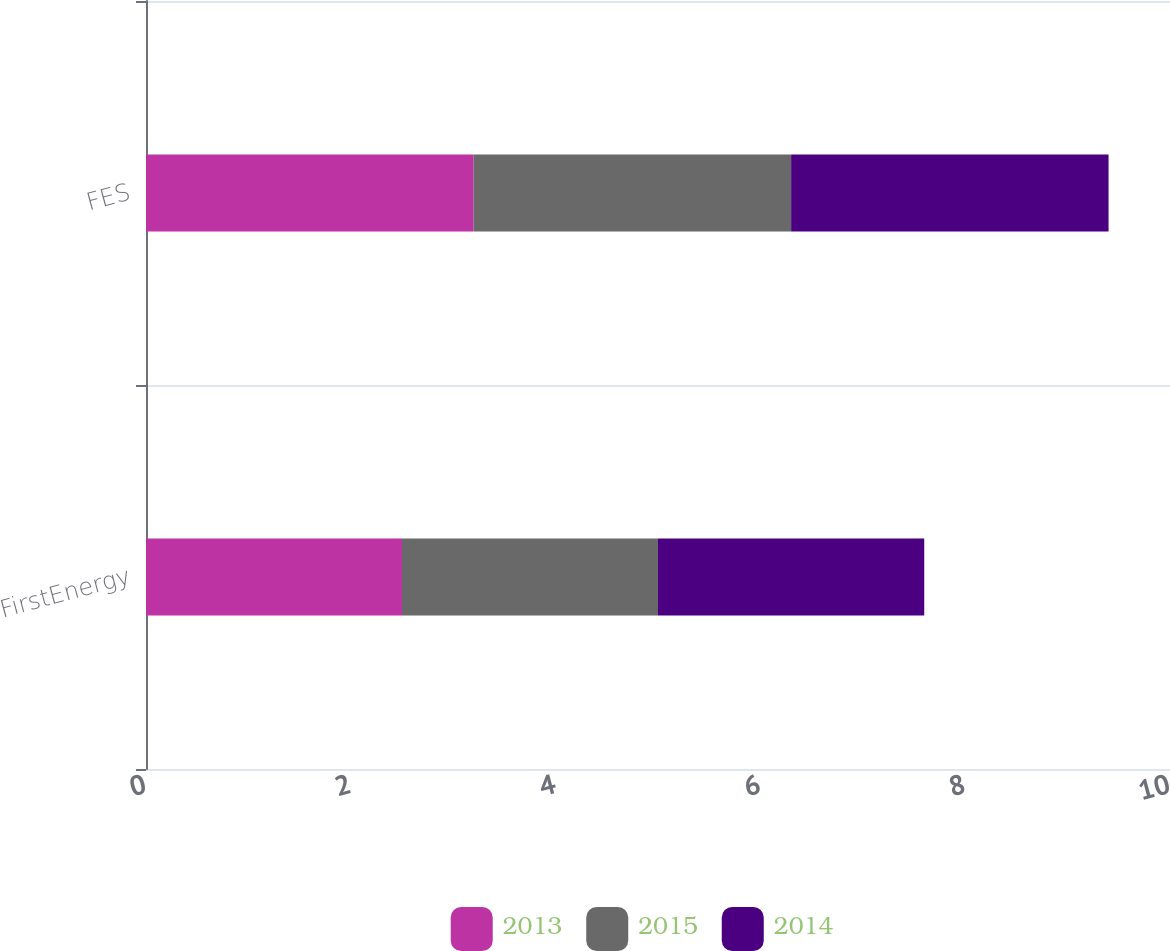<chart> <loc_0><loc_0><loc_500><loc_500><stacked_bar_chart><ecel><fcel>FirstEnergy<fcel>FES<nl><fcel>2013<fcel>2.5<fcel>3.2<nl><fcel>2015<fcel>2.5<fcel>3.1<nl><fcel>2014<fcel>2.6<fcel>3.1<nl></chart> 